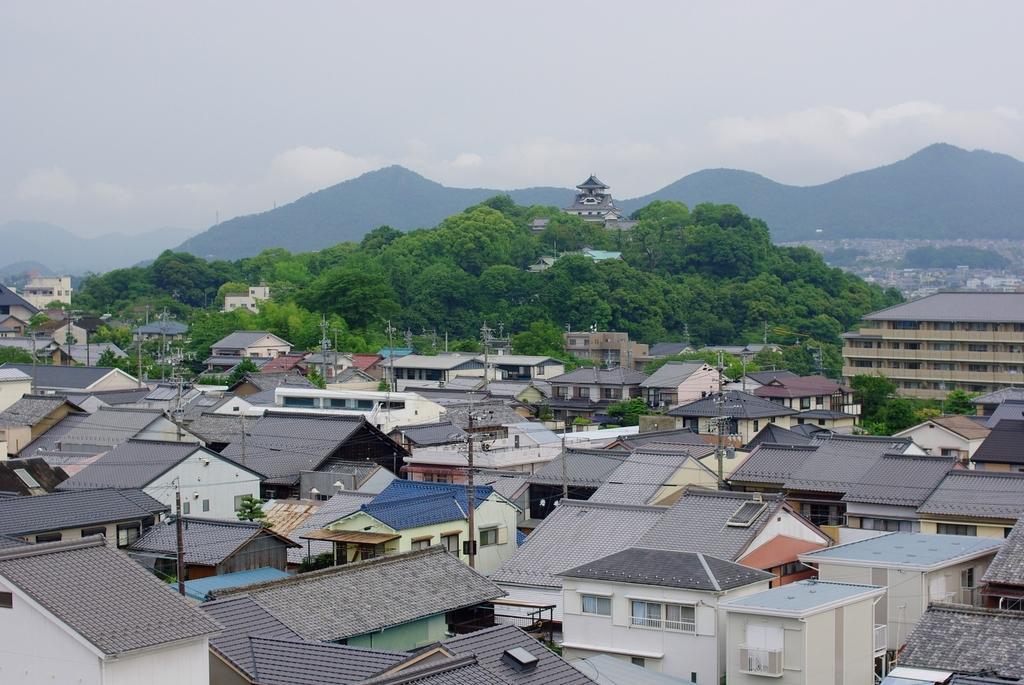How would you summarize this image in a sentence or two? In this image, we can see buildings, trees, houses, poles along with wires and we can see hills. At the top, there is sky. 